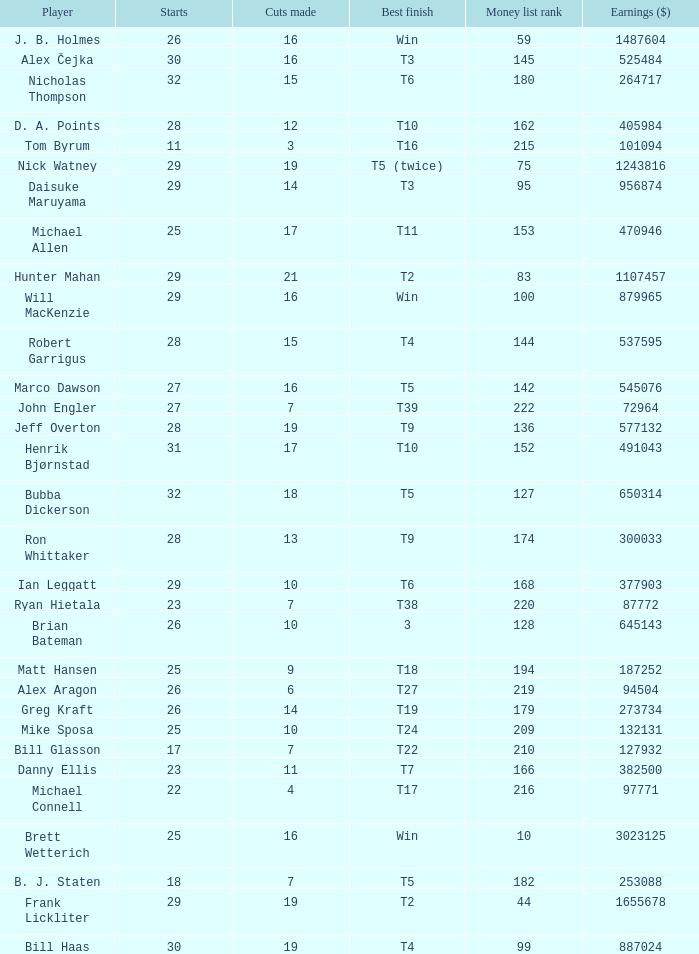What is the minimum number of cuts made for Hunter Mahan? 21.0. 